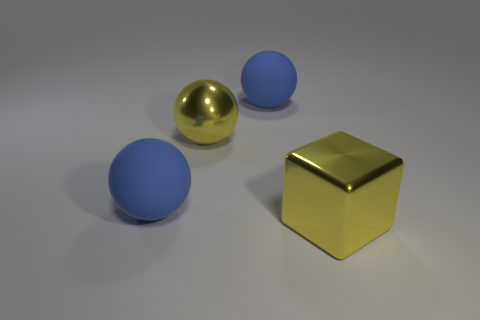There is a big yellow object on the left side of the large yellow metallic block; what number of metal blocks are right of it?
Offer a terse response. 1. How many cubes are tiny objects or large things?
Keep it short and to the point. 1. Is there a big rubber ball?
Make the answer very short. Yes. What shape is the big blue rubber thing to the left of the large blue ball that is behind the yellow metallic sphere?
Your answer should be very brief. Sphere. How many brown objects are metal balls or big metallic cubes?
Keep it short and to the point. 0. The cube is what color?
Give a very brief answer. Yellow. Is the size of the metallic block the same as the yellow sphere?
Make the answer very short. Yes. Is the big yellow sphere made of the same material as the blue object behind the large yellow metal sphere?
Keep it short and to the point. No. There is a cube that is in front of the yellow shiny ball; does it have the same color as the large metal sphere?
Your response must be concise. Yes. What number of big rubber things are both in front of the metal ball and to the right of the metallic ball?
Offer a very short reply. 0. 